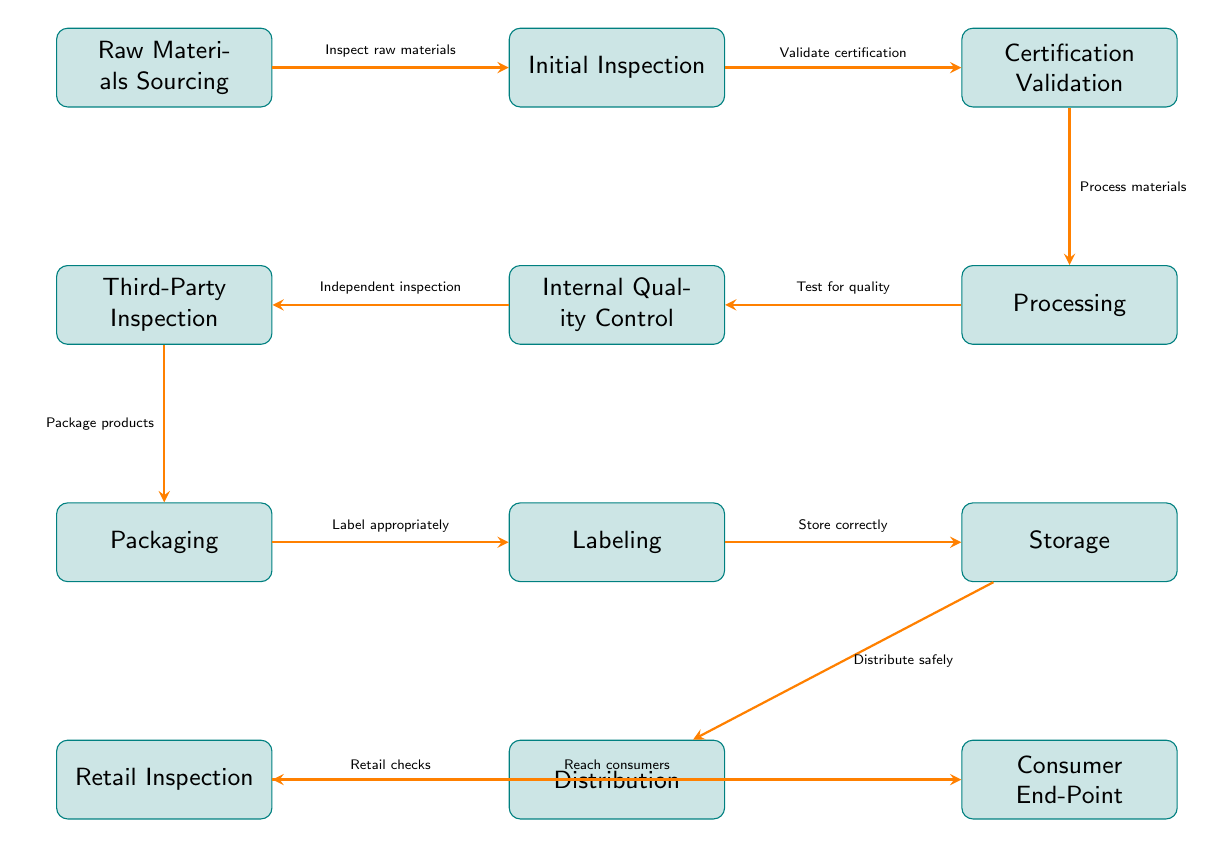What is the first step in the food safety compliance process? The diagram starts with "Raw Materials Sourcing," which is the first node in the flow.
Answer: Raw Materials Sourcing How many inspection points are depicted in the diagram? The diagram includes three inspection points: "Initial Inspection," "Third-Party Inspection," and "Retail Inspection."
Answer: 3 What follows after "Certification Validation" in the process? After "Certification Validation," the diagram shows the next step as "Processing." This can be determined by looking at the arrows connecting the nodes.
Answer: Processing Which node involves testing for quality? The node labeled "Internal Quality Control" is responsible for testing, as indicated in the process flow.
Answer: Internal Quality Control What is the final endpoint of the food chain process? The last node in the flow chart is labeled "Consumer End-Point," indicating where the process concludes.
Answer: Consumer End-Point Which stage of the process includes packaging products? "Packaging" is the specific node that handles packing the products, as shown in the flow from "Third-Party Inspection" to "Labeling."
Answer: Packaging What is the relationship between "Processing" and "Internal Quality Control"? "Internal Quality Control" follows "Processing" in the flow, which indicates that it checks the quality after the processing step is completed.
Answer: Testing for quality What happens before "Distribution"? Before "Distribution," the products must be correctly stored, as detailed in the arrow flow from "Storage" to "Distribution."
Answer: Storage Which node is related to consumer safety checks? The node labeled "Retail Inspection" is associated with safety checks before products reach consumers. It is a part of the "Retail" process of the food chain.
Answer: Retail Inspection 